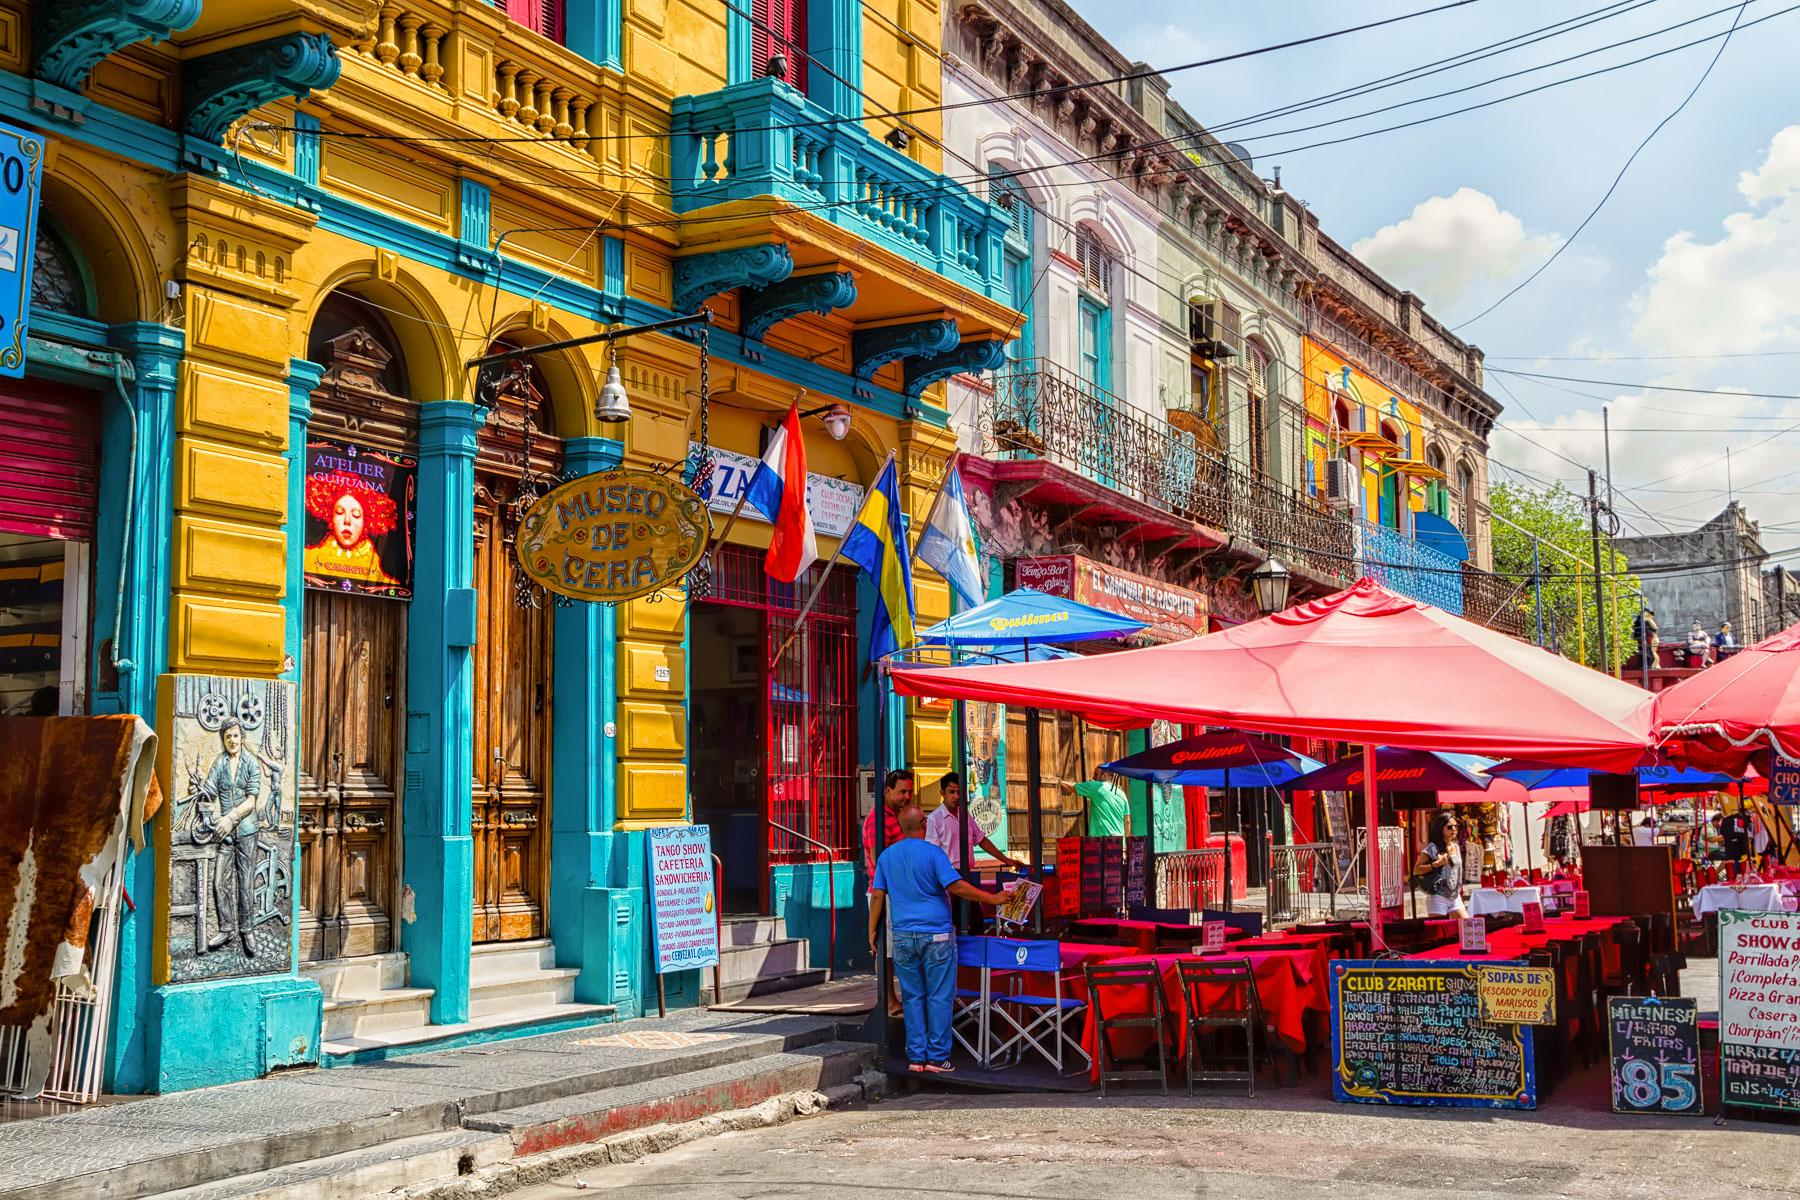What kind of activities can visitors engage in while in La Boca based on this scene? In La Boca, visitors can engage in a myriad of activities. They can explore the colorful streets, taking in the vibrant murals and architecturally unique buildings. The outdoor seating areas suggest that there are numerous dining options where visitors can enjoy local cuisine, possibly accompanied by live music or dance performances. The presence of a wax museum and tango show advertisements indicate that cultural entertainment is also prevalent. Souvenir shopping, as denoted by street vendors, and simply people-watching in this animated neighborhood could also be enjoyable. What historical influences might have shaped the architectural style of La Boca? La Boca's architectural style is heavily influenced by its history as an immigrant neighborhood, particularly from Italians, who settled there in the late 19th and early 20th centuries. The colorful buildings are a hallmark of Italian influence, inspired by the homes of Genoa, Italy. The usage of corrugated metal and vibrant paint was a practical choice originally, using leftover ship materials, which eventually became a distinctive aesthetic. The intricate balconies and ornate designs reflect European influences, blending functionality with artistic expression. Imagine a festival taking place in this street. What would it be like? Imagine a bustling festival in this vibrant street of La Boca. The already colorful buildings are adorned with even more decorations, as bunting and banners flutter in the breeze. Street performers, including tango dancers and musicians, entertain crowds on makeshift stages. The air is filled with the tantalizing aromas of local Argentine dishes being cooked at numerous food stalls. Artists set up booths displaying their works, some creating live paintings capturing the lively atmosphere. Locals and tourists alike dance together, while children play traditional games. The energy is infectious, making it a celebration of culture, music, and community. 